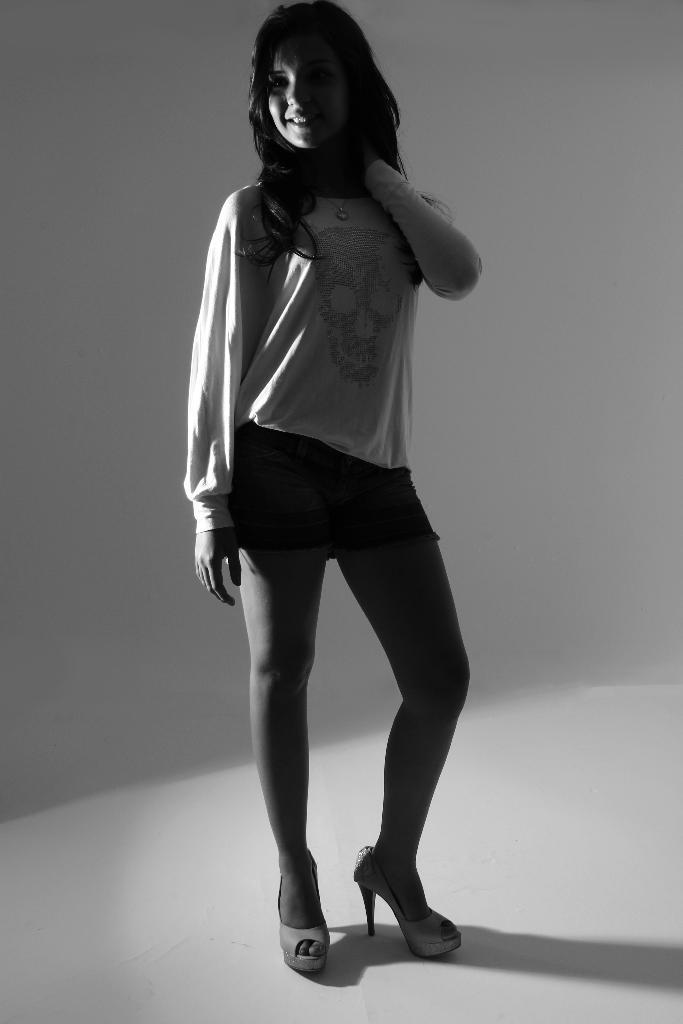Please provide a concise description of this image. This is a black and white image. There is a woman standing in the middle. She is wearing T-shirt. She is smiling. 